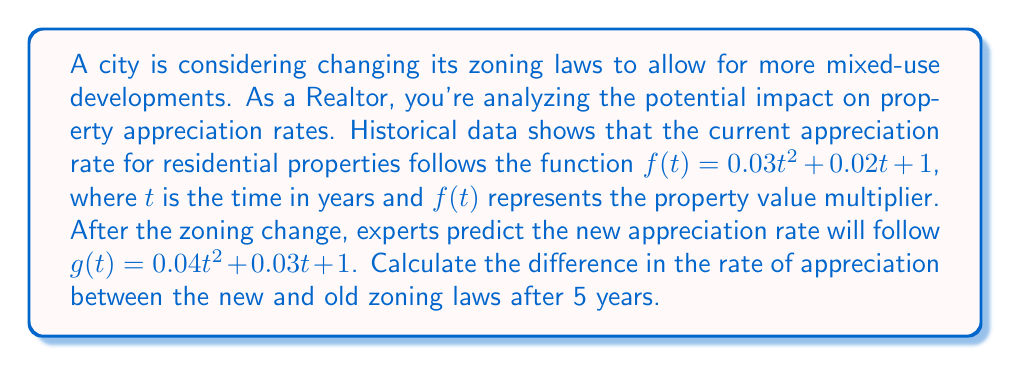Teach me how to tackle this problem. To solve this problem, we need to find the rate of appreciation for both functions at $t = 5$ years and then calculate the difference. The rate of appreciation is given by the derivative of each function.

1. For the original function $f(t) = 0.03t^2 + 0.02t + 1$:
   $f'(t) = 0.06t + 0.02$
   At $t = 5$: $f'(5) = 0.06(5) + 0.02 = 0.32$

2. For the new function $g(t) = 0.04t^2 + 0.03t + 1$:
   $g'(t) = 0.08t + 0.03$
   At $t = 5$: $g'(5) = 0.08(5) + 0.03 = 0.43$

3. The difference in the rate of appreciation:
   $g'(5) - f'(5) = 0.43 - 0.32 = 0.11$

This means that after 5 years, the rate of appreciation under the new zoning laws will be 0.11 (or 11 percentage points) higher than under the old zoning laws.
Answer: 0.11 